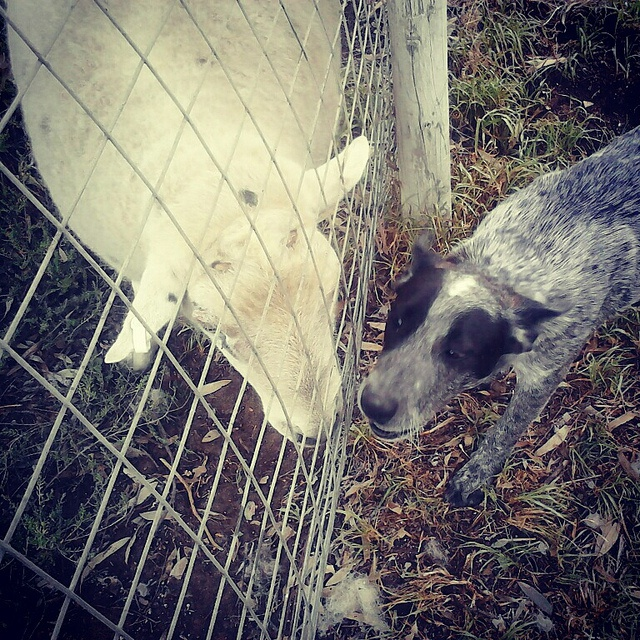Describe the objects in this image and their specific colors. I can see sheep in black, beige, darkgray, lightyellow, and tan tones and dog in black, gray, darkgray, and navy tones in this image. 